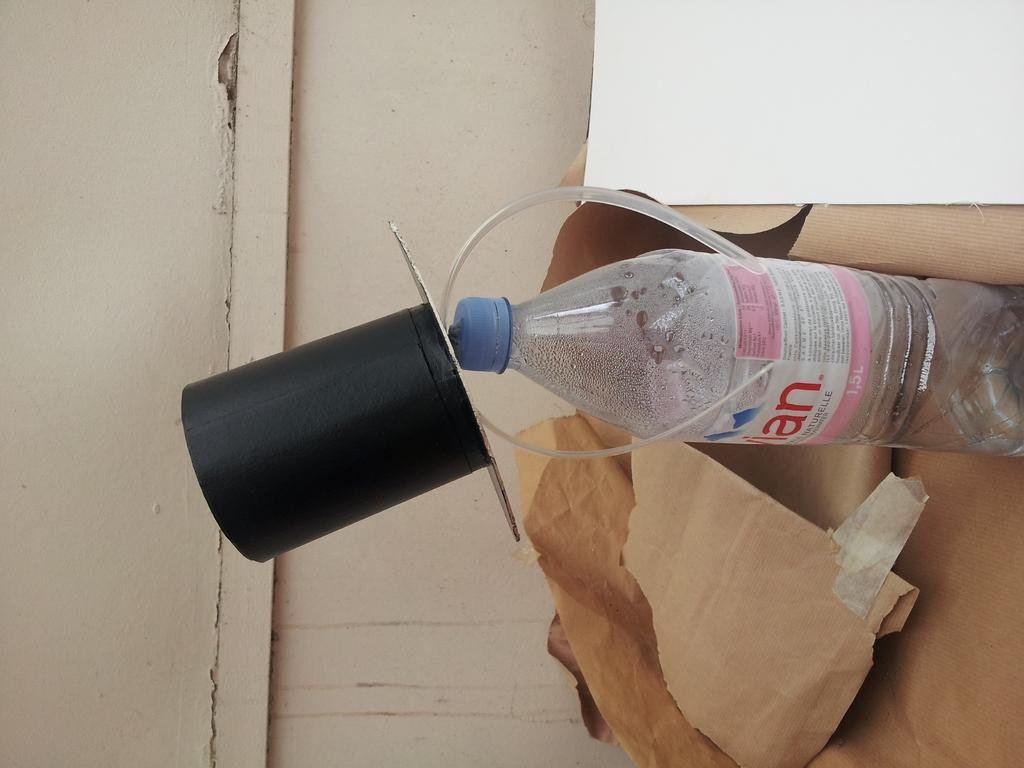Provide a one-sentence caption for the provided image. An Evian water bottle with a hate is sticking out of a paper bag. 